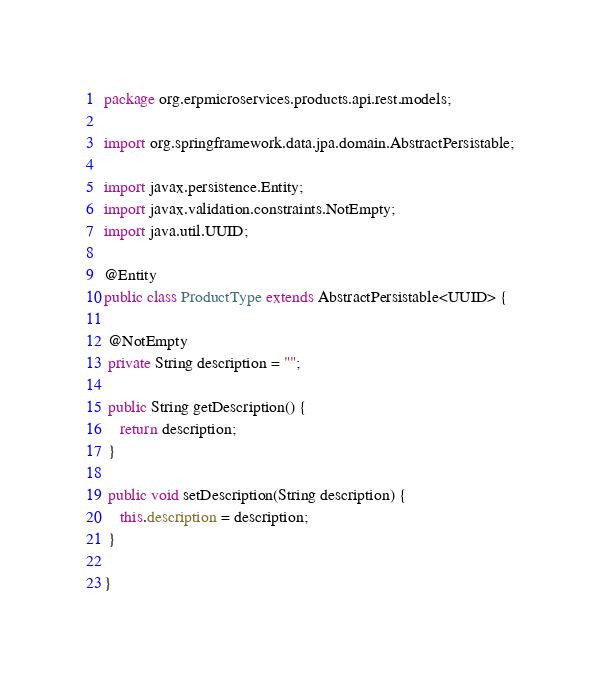<code> <loc_0><loc_0><loc_500><loc_500><_Java_>package org.erpmicroservices.products.api.rest.models;

import org.springframework.data.jpa.domain.AbstractPersistable;

import javax.persistence.Entity;
import javax.validation.constraints.NotEmpty;
import java.util.UUID;

@Entity
public class ProductType extends AbstractPersistable<UUID> {

 @NotEmpty
 private String description = "";

 public String getDescription() {
	return description;
 }

 public void setDescription(String description) {
	this.description = description;
 }

}
</code> 